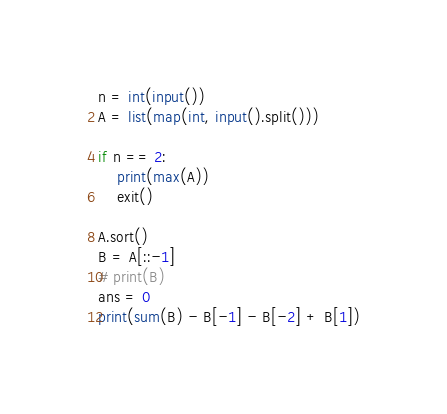Convert code to text. <code><loc_0><loc_0><loc_500><loc_500><_Python_>

n = int(input())
A = list(map(int, input().split()))

if n == 2:
    print(max(A))
    exit()

A.sort()
B = A[::-1]
# print(B)
ans = 0
print(sum(B) - B[-1] - B[-2] + B[1])
</code> 